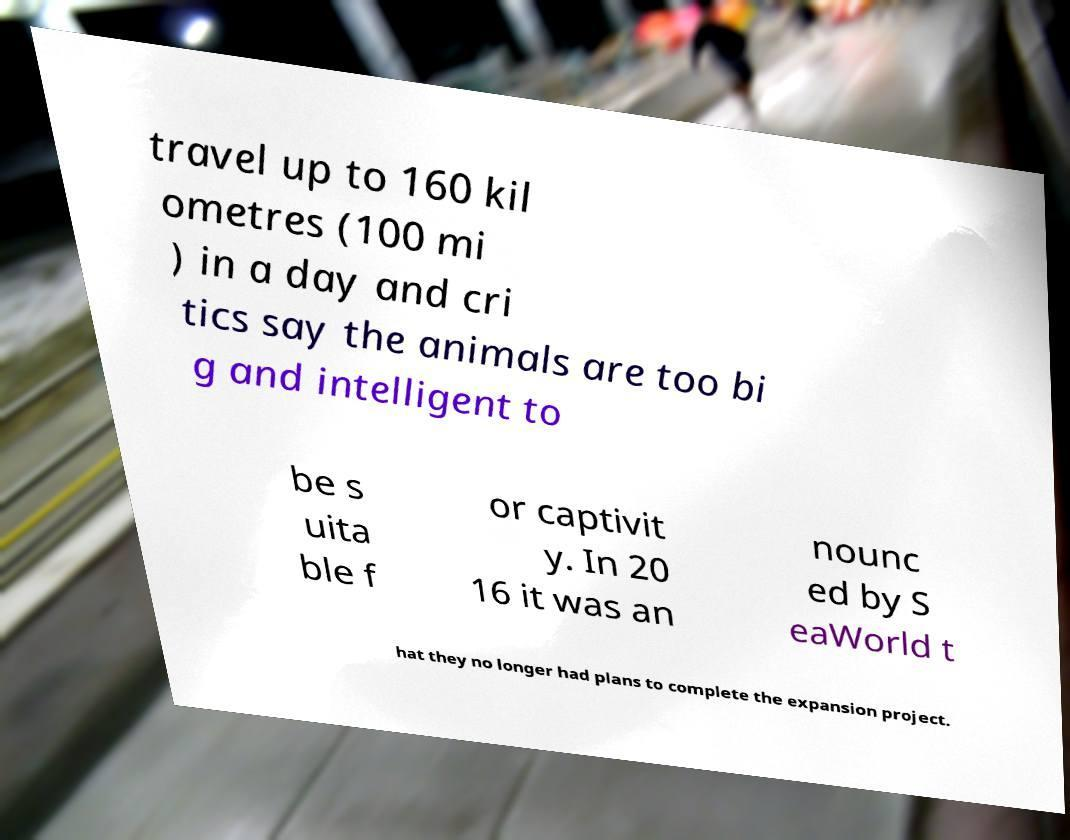Please read and relay the text visible in this image. What does it say? travel up to 160 kil ometres (100 mi ) in a day and cri tics say the animals are too bi g and intelligent to be s uita ble f or captivit y. In 20 16 it was an nounc ed by S eaWorld t hat they no longer had plans to complete the expansion project. 